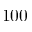<formula> <loc_0><loc_0><loc_500><loc_500>1 0 0</formula> 